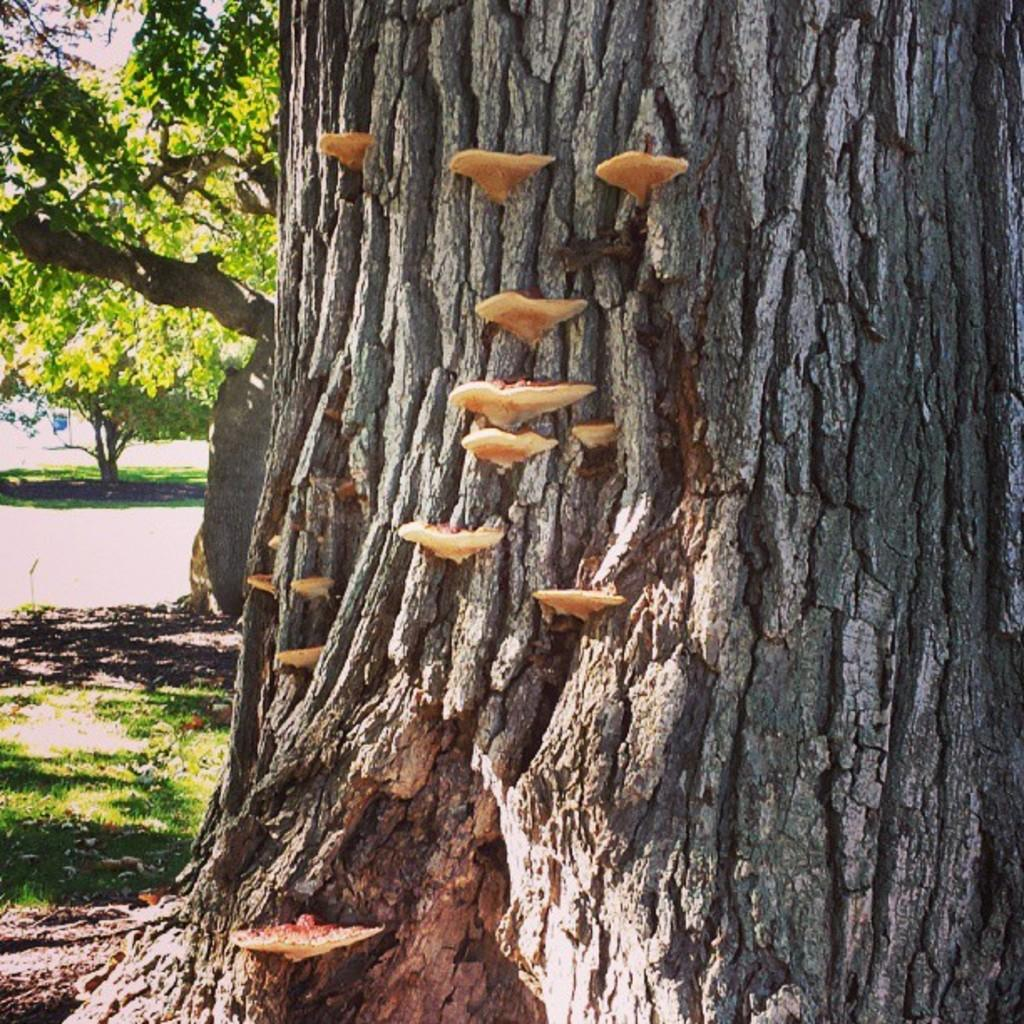What colors are the objects in the image? The objects in the image have cream and brown colors. What is the connection between these objects and a tree? These objects are associated with a tree, which suggests they might be part of the tree or its surroundings. What can be seen in the background of the image? There are more trees visible in the background of the image, as well as the sky. What type of brick is being used to build the sun in the image? There is no brick or sun present in the image; it features objects associated with a tree and a background with more trees and the sky. What kind of bait is being used to attract the creatures in the image? There is no bait or creatures present in the image; it only shows objects associated with a tree and the background. 